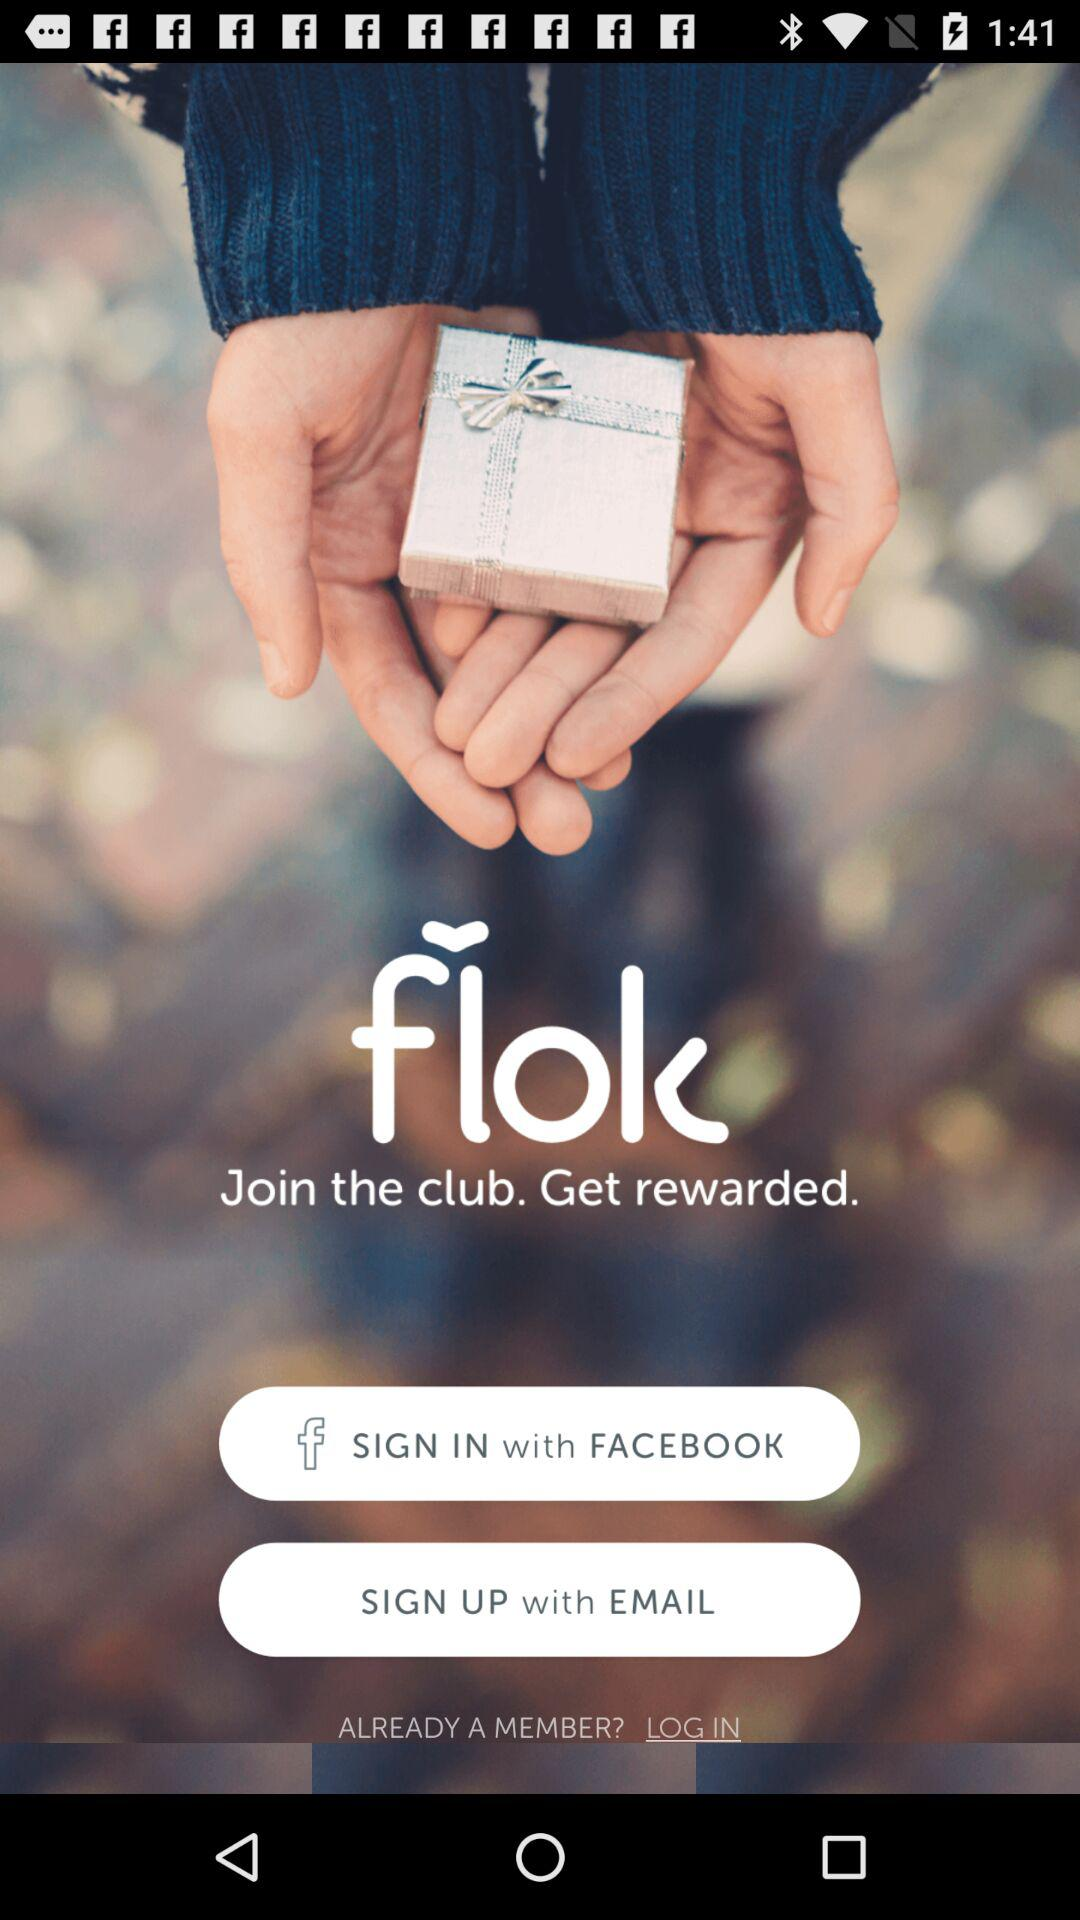Through what account can we sign up? You can sign up through "EMAIL". 